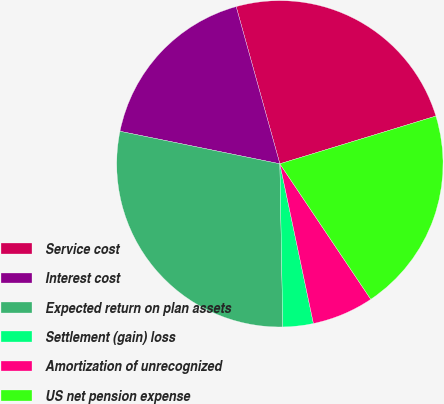Convert chart. <chart><loc_0><loc_0><loc_500><loc_500><pie_chart><fcel>Service cost<fcel>Interest cost<fcel>Expected return on plan assets<fcel>Settlement (gain) loss<fcel>Amortization of unrecognized<fcel>US net pension expense<nl><fcel>24.59%<fcel>17.49%<fcel>28.48%<fcel>3.01%<fcel>6.11%<fcel>20.32%<nl></chart> 